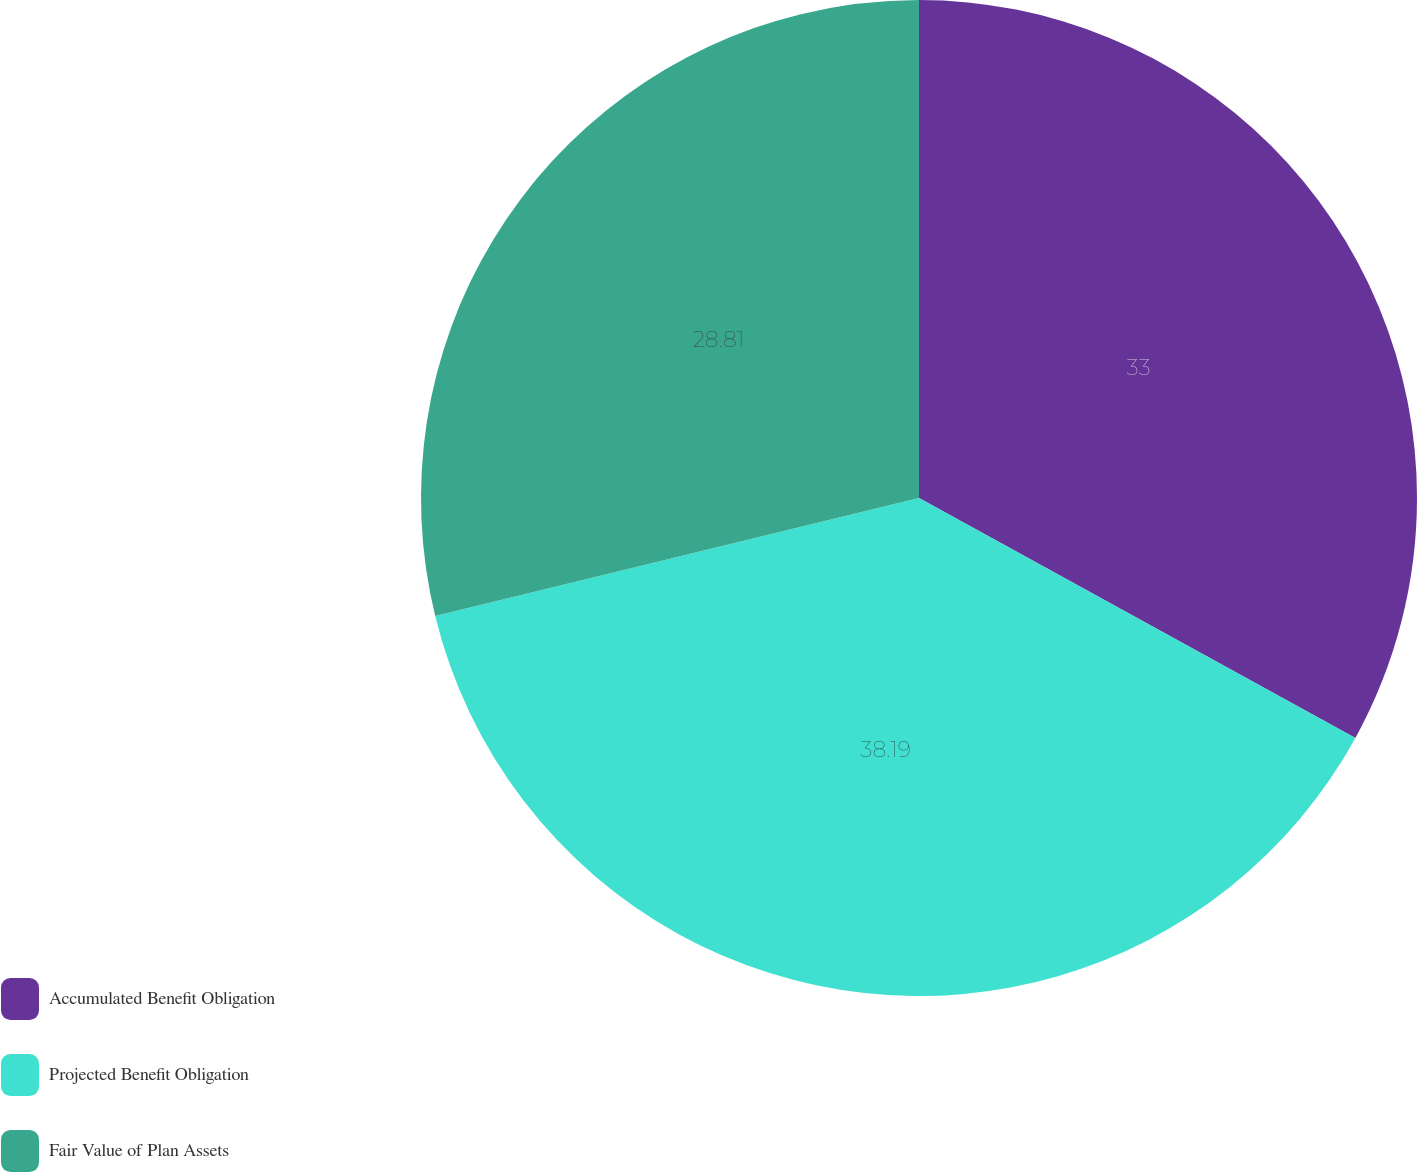<chart> <loc_0><loc_0><loc_500><loc_500><pie_chart><fcel>Accumulated Benefit Obligation<fcel>Projected Benefit Obligation<fcel>Fair Value of Plan Assets<nl><fcel>33.0%<fcel>38.19%<fcel>28.81%<nl></chart> 